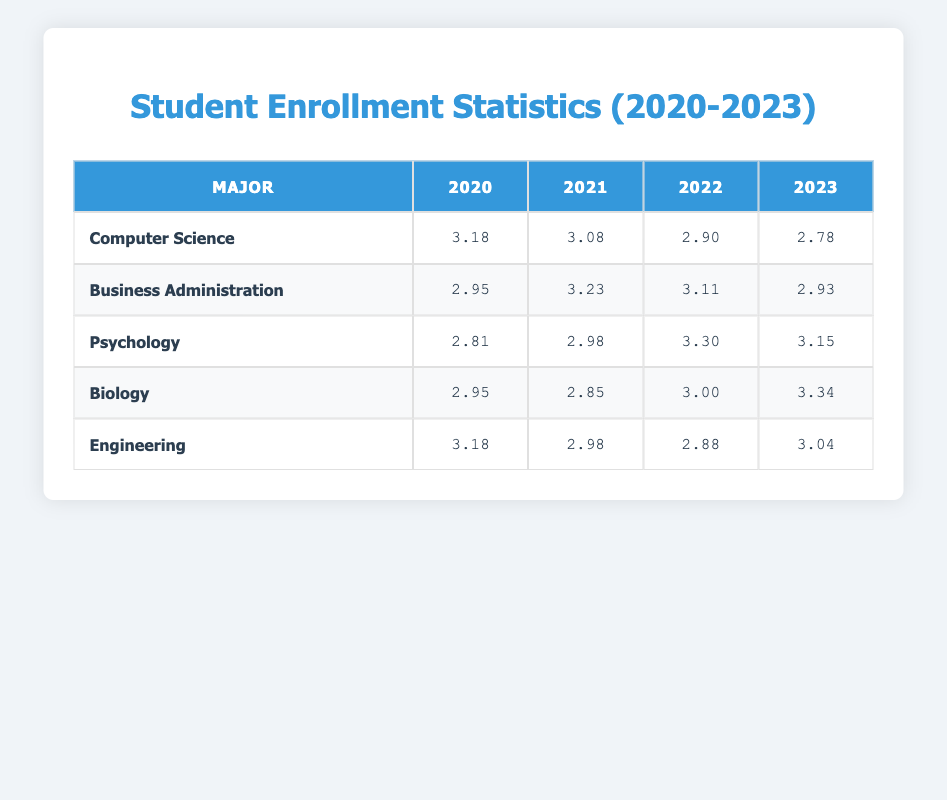What was the enrollment in Computer Science in 2022? The table shows that the enrollment for Computer Science in 2022 is represented by the logarithmic value 3.30. The original value can be found by calculating the antilogarithm, which corresponds to 2000 students.
Answer: 2000 What is the logarithmic value for Psychology in 2021? Referring to the table, the logarithmic value for Psychology in 2021 is 2.93.
Answer: 2.93 Which major had the highest enrollment in 2023? In the table, Computer Science shows the highest enrollment value of 2200 students for the year 2023, which is more than the other listed majors.
Answer: Computer Science What is the average logarithmic value of Engineering from 2020 to 2023? The logarithmic values for Engineering from 2020 to 2023 are 2.95, 2.98, 3.00, and 3.04. To calculate the average, we sum these values (2.95 + 2.98 + 3.00 + 3.04 = 11.97) and divide by 4, giving us an average of 2.9925.
Answer: 2.99 Is there an increase in enrollment for Business Administration from 2020 to 2023? By looking at the values, Business Administration had 1200 students in 2020 and increased to 1500 by 2023, indicating a clear increase over these years.
Answer: Yes What was the total logarithmic enrollment for all majors in 2022? The individual logarithmic values for the majors in 2022 are 3.30, 3.15, 2.95, 2.85, and 3.00. Summing these values gives us 3.30 + 3.15 + 2.95 + 2.85 + 3.00 = 15.25 as the total logarithmic value for all majors in 2022.
Answer: 15.25 How many students were enrolled in Biology in 2020? The table indicates that the enrollment in Biology for the year 2020 corresponds to the logarithmic value 2.78. By calculating the antilogarithm, we find the enrollment was 600 students.
Answer: 600 Which major exhibited the smallest increase in enrollment between 2020 and 2023 based on the logarithmic values? Assessing the values, Psychology increased from 2.90 (800 students) to 2.98 (950 students), a difference of 0.08. In comparison, the increases for other majors are higher. Thus, Psychology had the smallest increase.
Answer: Psychology 